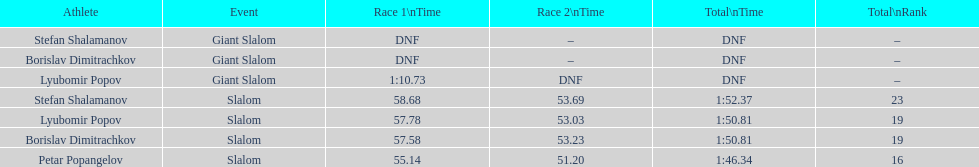How long did it take for lyubomir popov to finish the giant slalom in race 1? 1:10.73. 